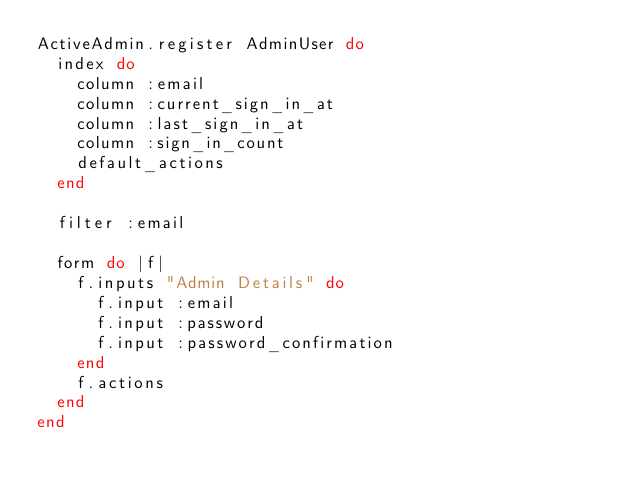Convert code to text. <code><loc_0><loc_0><loc_500><loc_500><_Ruby_>ActiveAdmin.register AdminUser do
  index do
    column :email
    column :current_sign_in_at
    column :last_sign_in_at
    column :sign_in_count
    default_actions
  end

  filter :email

  form do |f|
    f.inputs "Admin Details" do
      f.input :email
      f.input :password
      f.input :password_confirmation
    end
    f.actions
  end
end
</code> 